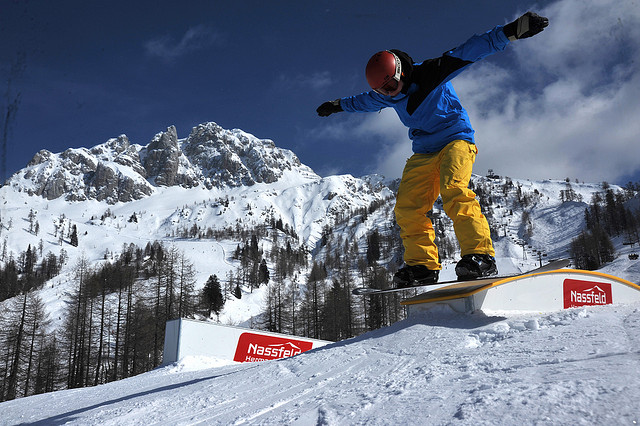Is the snowboarder airborne or on the ground? The snowboarder is currently airborne, having launched off the ground to perform a trick on a rail. This mid-air position is a key moment in executing snowboarding stunts. 